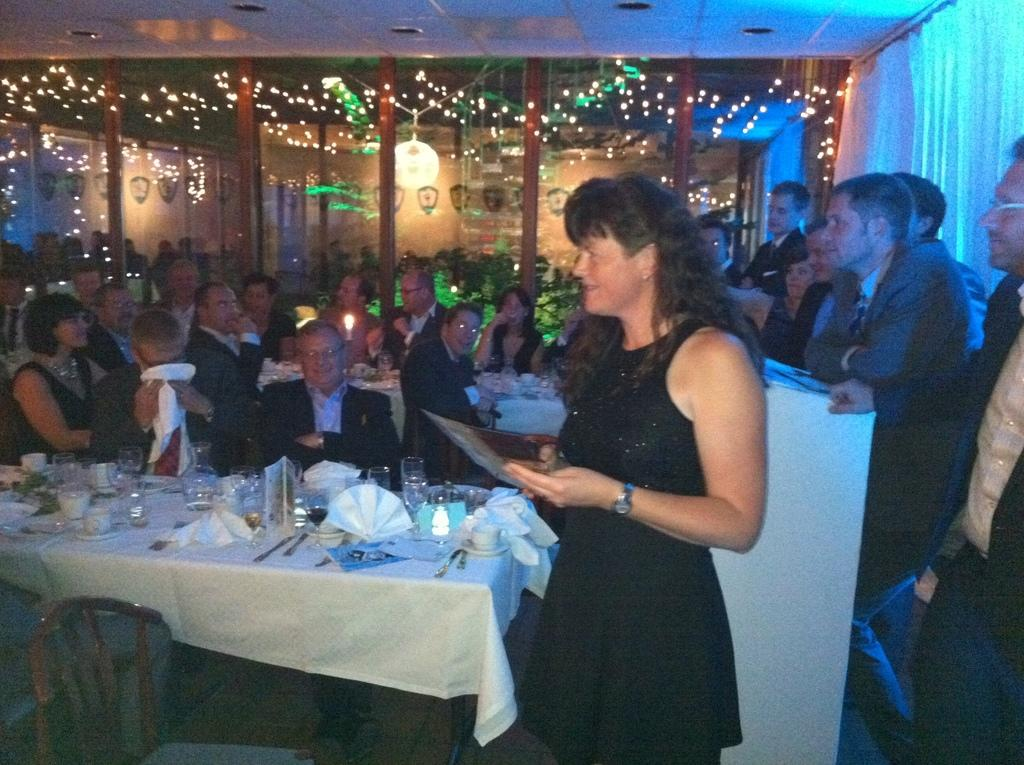What are the people in the image doing? There are people sitting on chairs and standing in the image. Can you describe the woman in the image? There is a woman standing in the image. How many people are standing in the image? There are people standing in the image, but the exact number is not specified. What type of stocking is the woman wearing in the image? There is no information about the woman's clothing, including stockings, in the image. 